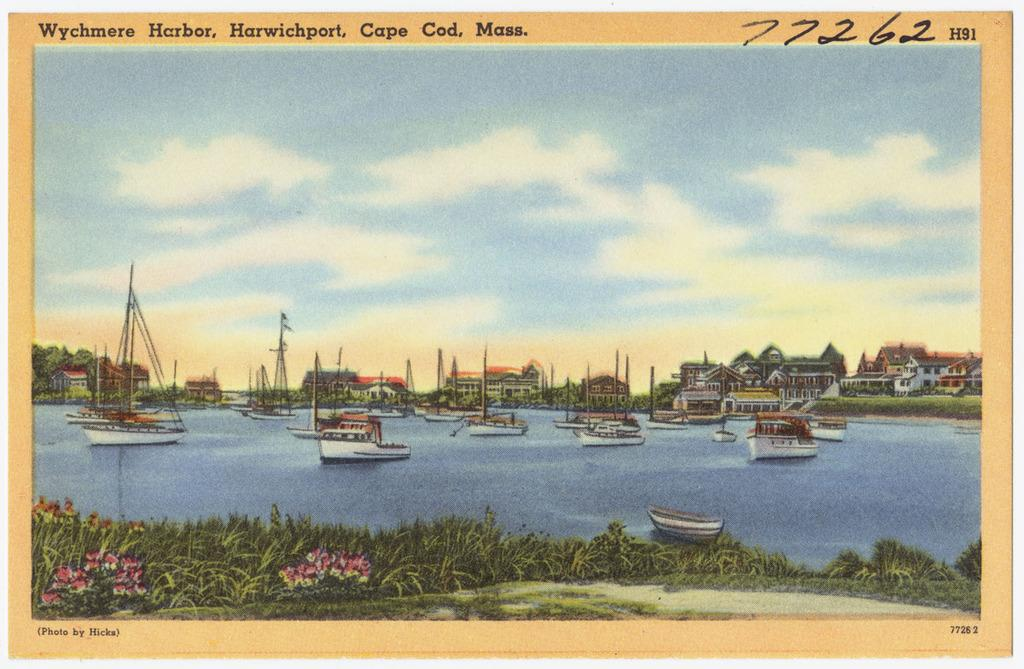<image>
Offer a succinct explanation of the picture presented. A picture with several boats on the water is labeled as Wychmere Harbor. 